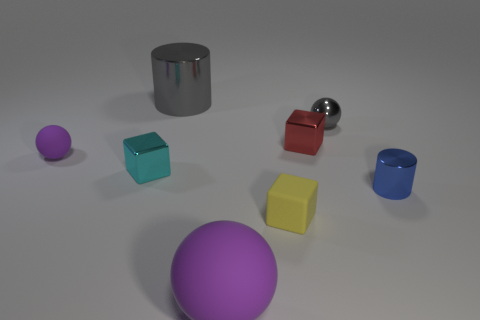Add 2 blue shiny cylinders. How many objects exist? 10 Subtract all cylinders. How many objects are left? 6 Subtract 1 cyan blocks. How many objects are left? 7 Subtract all small matte blocks. Subtract all blue cylinders. How many objects are left? 6 Add 5 gray metal spheres. How many gray metal spheres are left? 6 Add 3 brown cylinders. How many brown cylinders exist? 3 